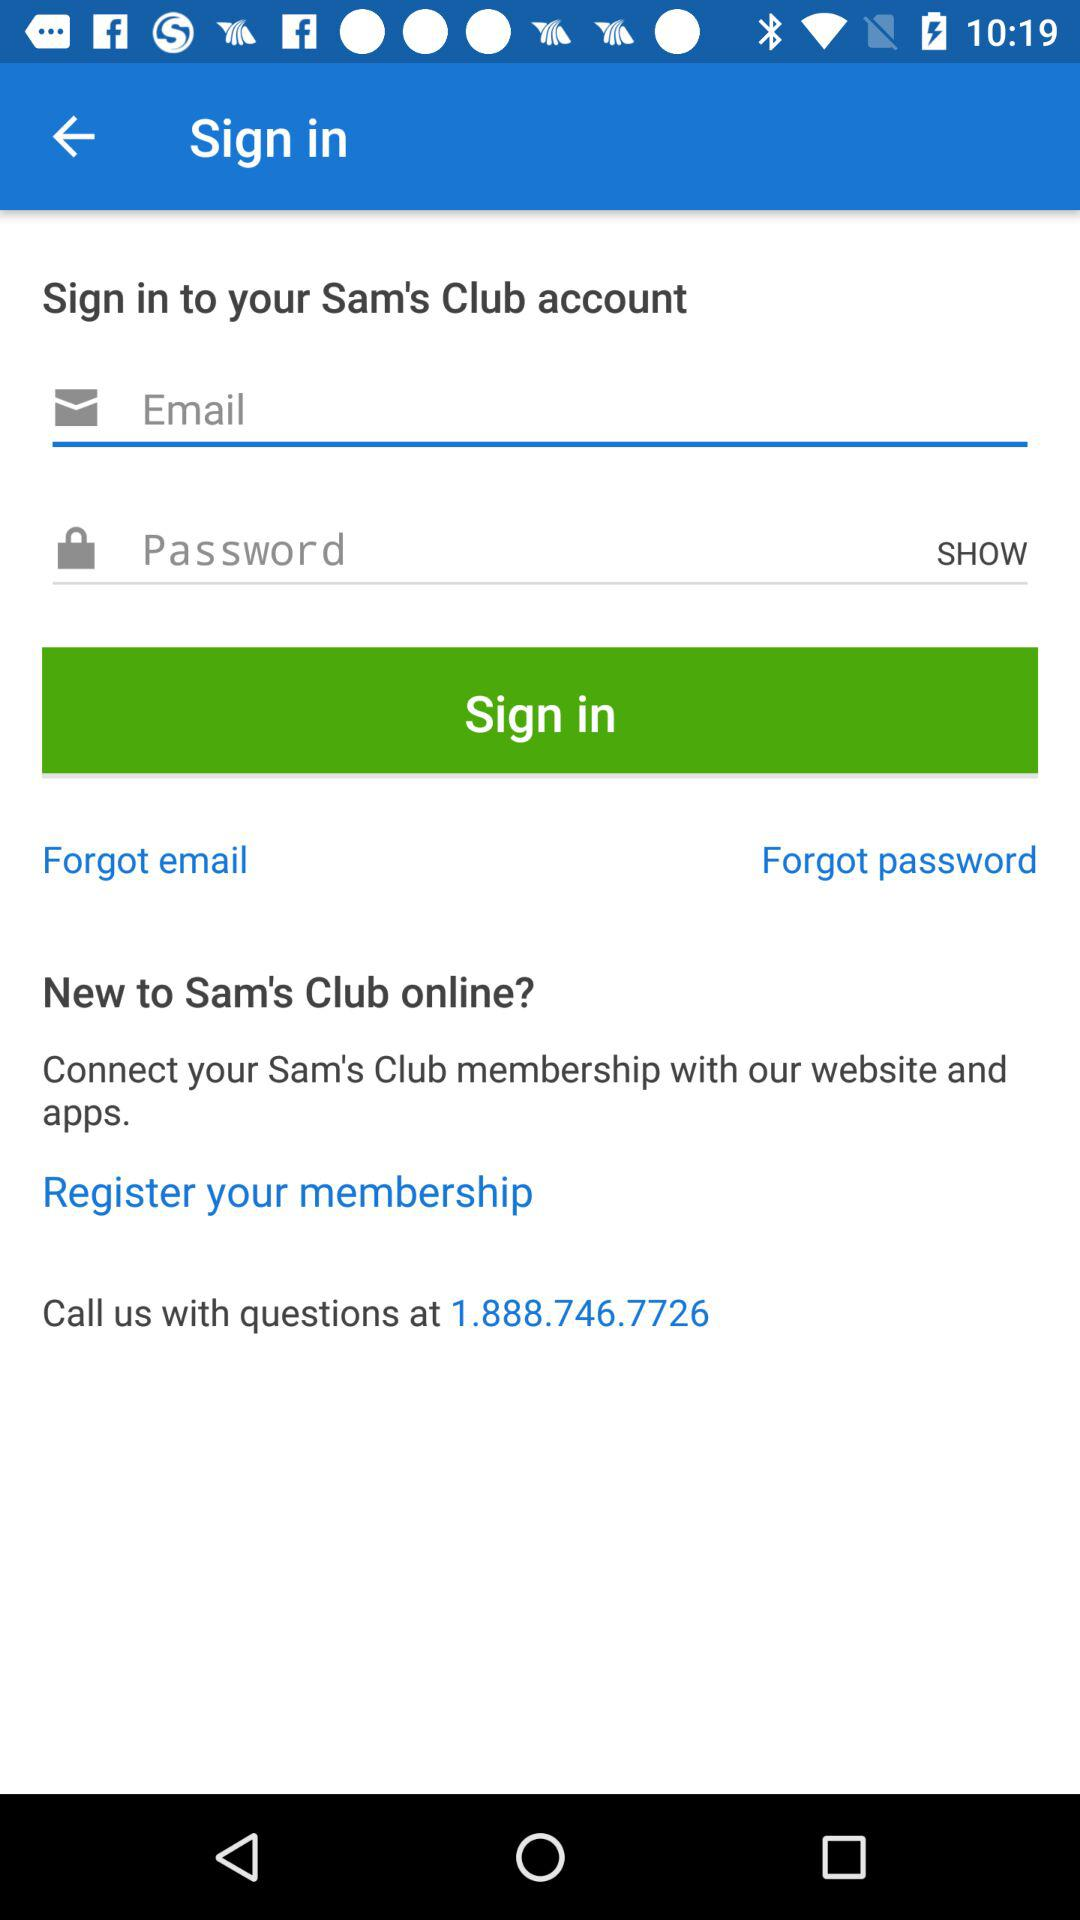How many input fields are there for signing in?
Answer the question using a single word or phrase. 2 